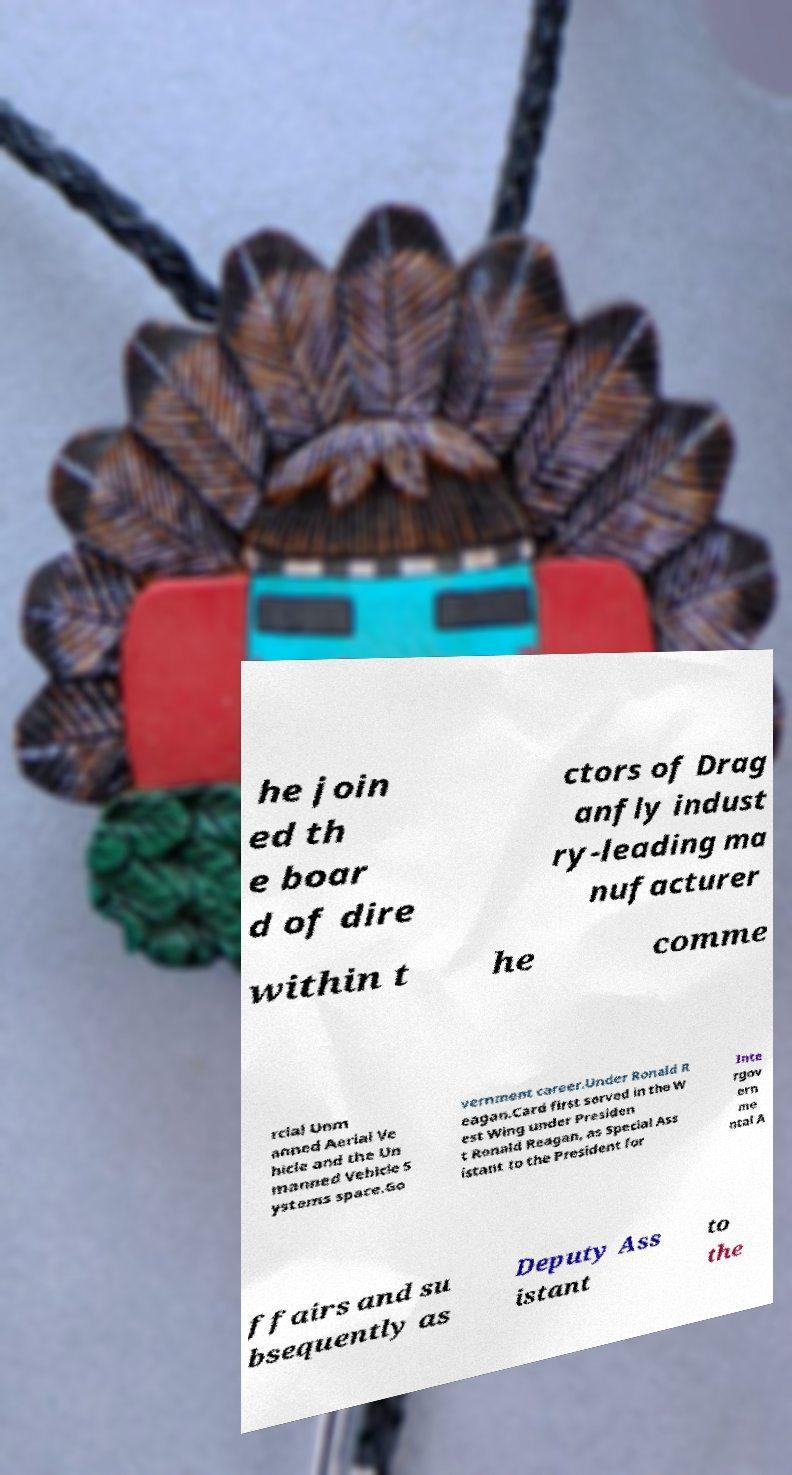Can you read and provide the text displayed in the image?This photo seems to have some interesting text. Can you extract and type it out for me? he join ed th e boar d of dire ctors of Drag anfly indust ry-leading ma nufacturer within t he comme rcial Unm anned Aerial Ve hicle and the Un manned Vehicle S ystems space.Go vernment career.Under Ronald R eagan.Card first served in the W est Wing under Presiden t Ronald Reagan, as Special Ass istant to the President for Inte rgov ern me ntal A ffairs and su bsequently as Deputy Ass istant to the 